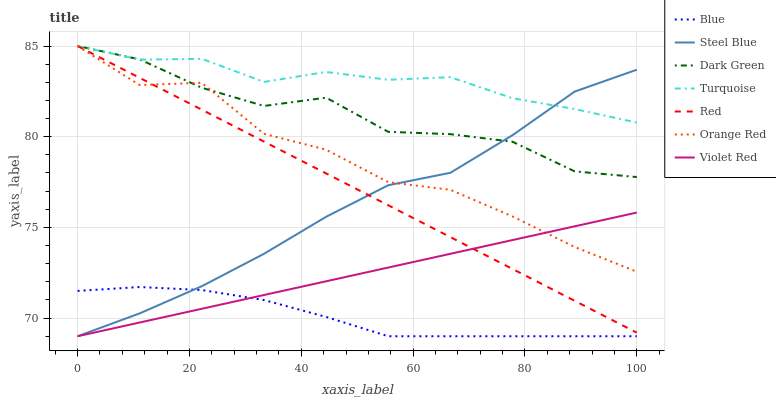Does Blue have the minimum area under the curve?
Answer yes or no. Yes. Does Turquoise have the maximum area under the curve?
Answer yes or no. Yes. Does Violet Red have the minimum area under the curve?
Answer yes or no. No. Does Violet Red have the maximum area under the curve?
Answer yes or no. No. Is Violet Red the smoothest?
Answer yes or no. Yes. Is Orange Red the roughest?
Answer yes or no. Yes. Is Turquoise the smoothest?
Answer yes or no. No. Is Turquoise the roughest?
Answer yes or no. No. Does Turquoise have the lowest value?
Answer yes or no. No. Does Dark Green have the highest value?
Answer yes or no. Yes. Does Violet Red have the highest value?
Answer yes or no. No. Is Blue less than Orange Red?
Answer yes or no. Yes. Is Orange Red greater than Blue?
Answer yes or no. Yes. Does Red intersect Violet Red?
Answer yes or no. Yes. Is Red less than Violet Red?
Answer yes or no. No. Is Red greater than Violet Red?
Answer yes or no. No. Does Blue intersect Orange Red?
Answer yes or no. No. 